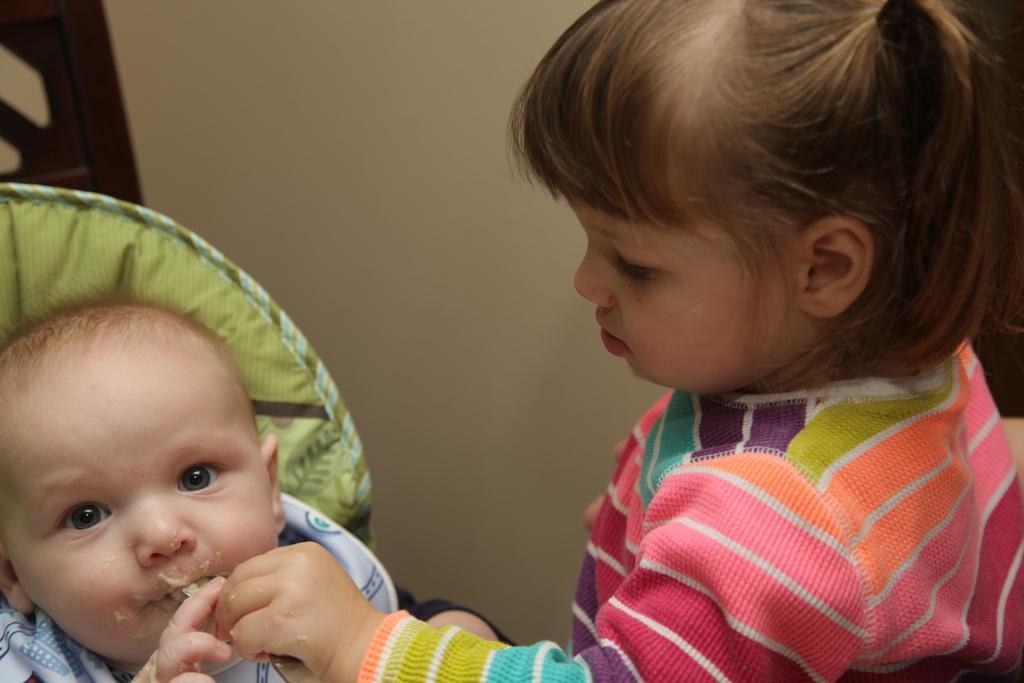Can you describe this image briefly? In the center of the image, we can see a child feeding a baby and in the background, there is a wall. 